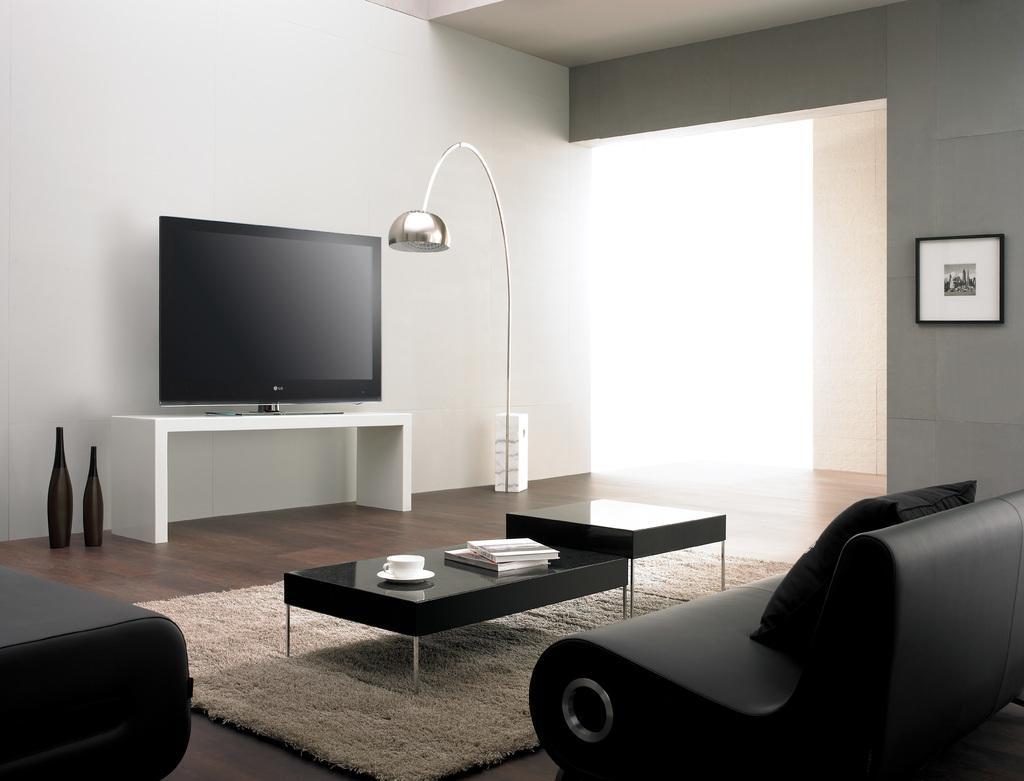How would you summarize this image in a sentence or two? It is a living room,there is a sofa set in front of the sofa there is a black table on the table there are some books and a cup and saucer,in front of that there is a television on the white table,to the left side there are some bottles,to the right side there is a big lamp in the background there is a window,to the right side there is another wall of grey color there is a photo frame to the wall. 